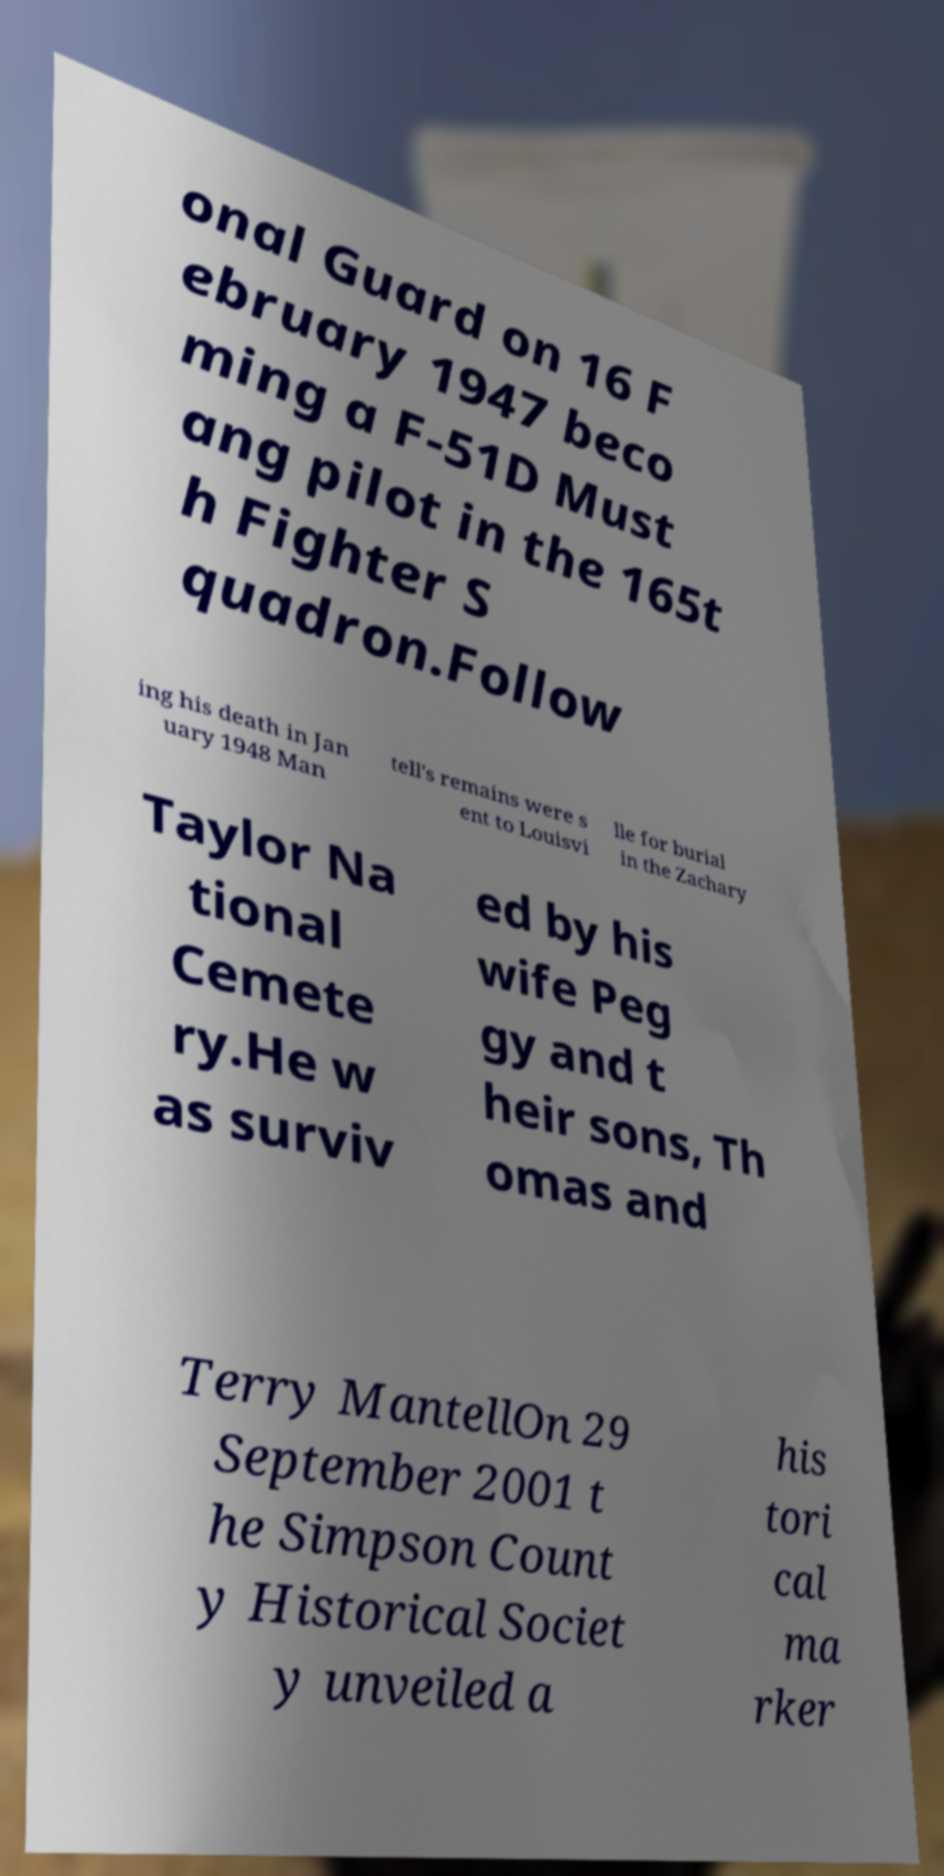For documentation purposes, I need the text within this image transcribed. Could you provide that? onal Guard on 16 F ebruary 1947 beco ming a F-51D Must ang pilot in the 165t h Fighter S quadron.Follow ing his death in Jan uary 1948 Man tell's remains were s ent to Louisvi lle for burial in the Zachary Taylor Na tional Cemete ry.He w as surviv ed by his wife Peg gy and t heir sons, Th omas and Terry MantellOn 29 September 2001 t he Simpson Count y Historical Societ y unveiled a his tori cal ma rker 